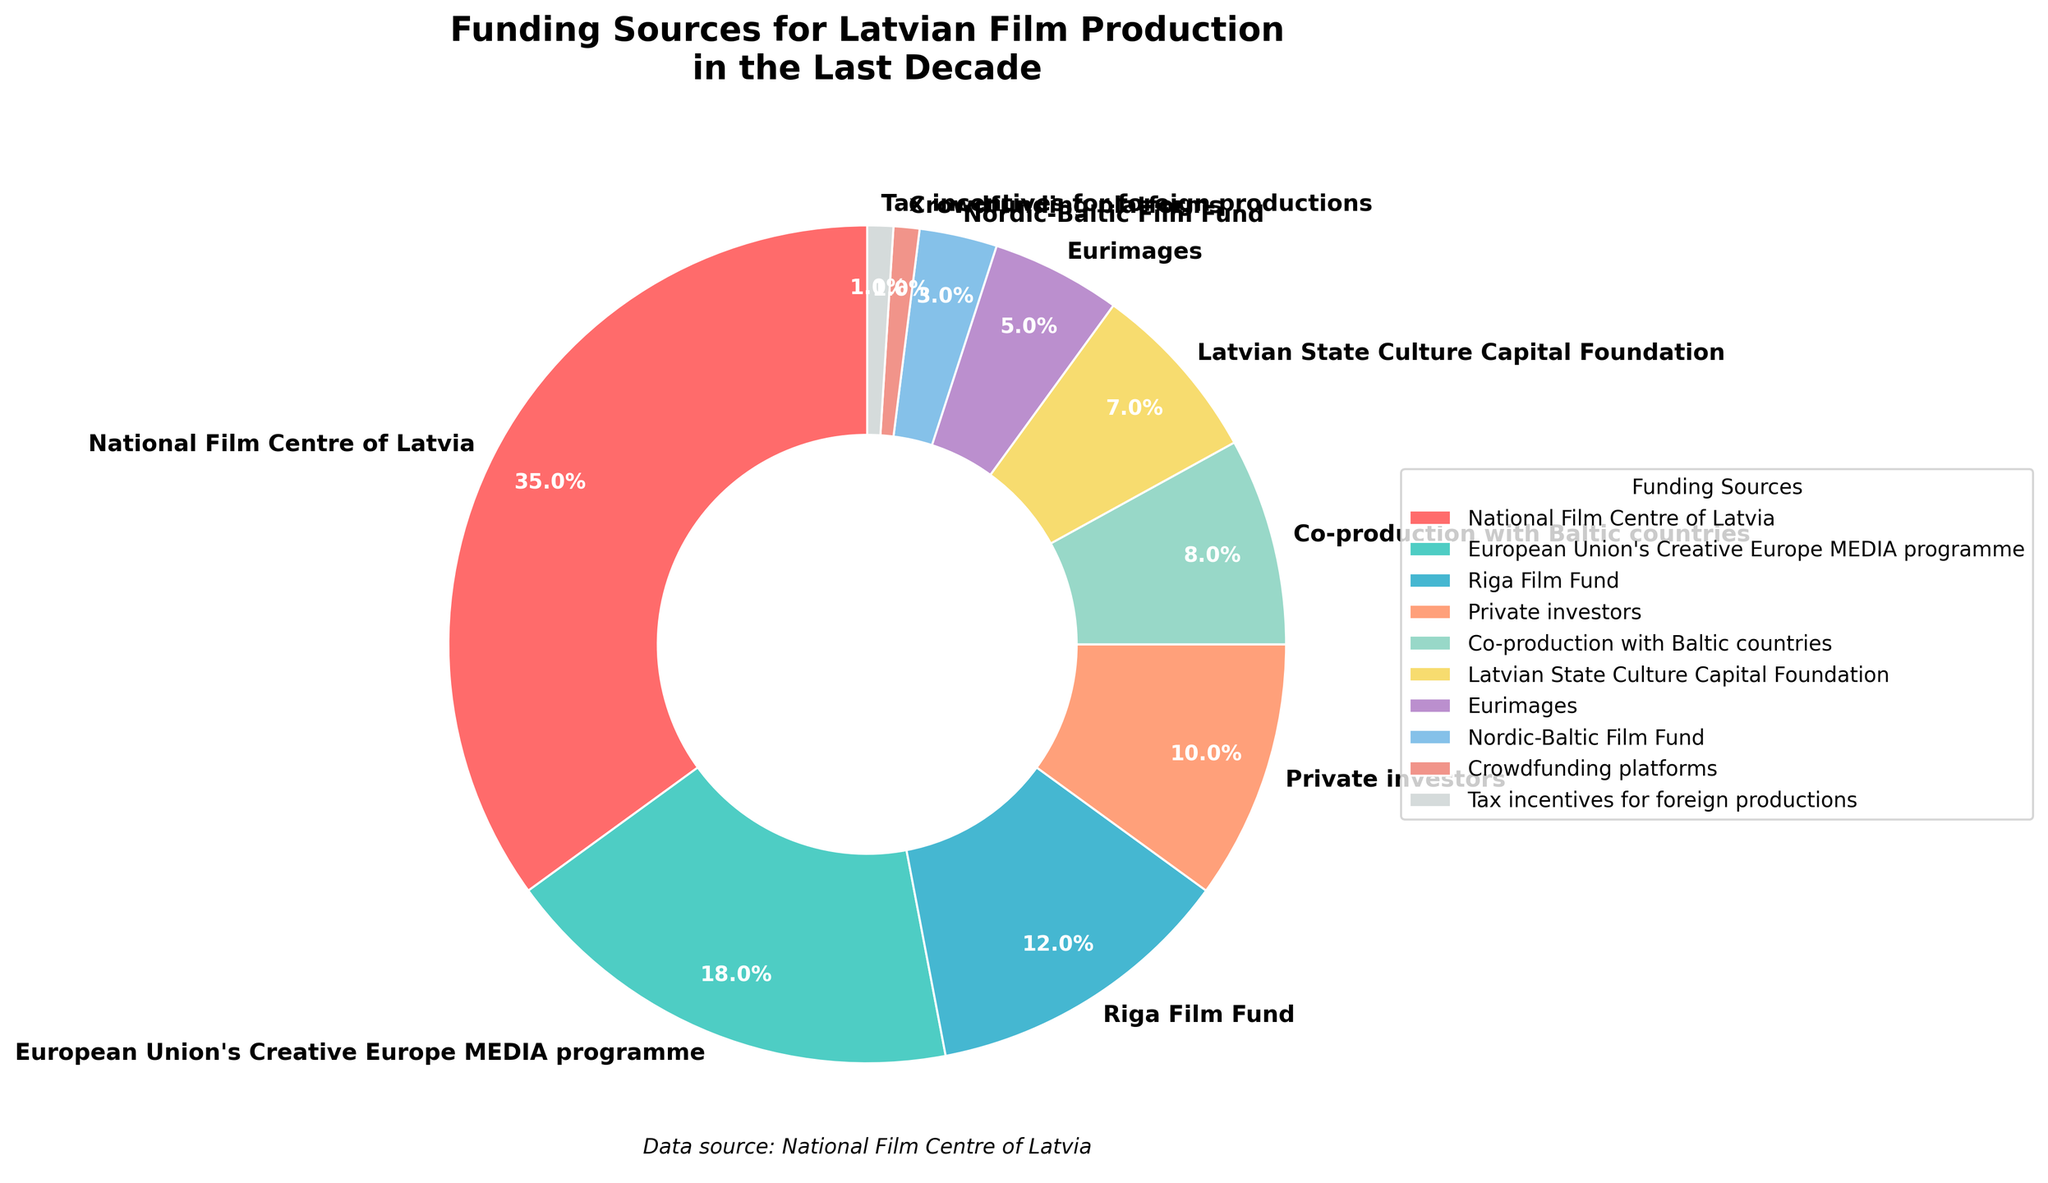Which funding source contributes the most to Latvian film production? The largest segment of the pie chart represents the National Film Centre of Latvia with 35%.
Answer: National Film Centre of Latvia How much more does the National Film Centre of Latvia contribute compared to Private investors? National Film Centre of Latvia contributes 35% and Private investors contribute 10%. The difference is 35% - 10% = 25%.
Answer: 25% Which funding sources contribute exactly 1% to Latvian film production? The smallest segments of the pie chart, each labelled with 1%, correspond to Crowdfunding platforms and Tax incentives for foreign productions.
Answer: Crowdfunding platforms, Tax incentives for foreign productions What is the combined contribution of the European Union's Creative Europe MEDIA programme and the Riga Film Fund? European Union's Creative Europe MEDIA programme contributes 18% and Riga Film Fund contributes 12%. The combined contribution is 18% + 12% = 30%.
Answer: 30% Which funding source has the second highest contribution to Latvian film production? The second largest segment of the pie chart represents the European Union's Creative Europe MEDIA programme with 18%.
Answer: European Union's Creative Europe MEDIA programme What is the combined contribution of all international sources (European Union's Creative Europe MEDIA programme, European co-production funds, and regional funds)? The relevant funding sources are European Union's Creative Europe MEDIA programme (18%), Eurimages (5%), and Nordic-Baltic Film Fund (3%). Their combined contribution is 18% + 5% + 3% = 26%.
Answer: 26% Is the contribution of the Riga Film Fund greater than the combined contribution of Latvian State Culture Capital Foundation and Nordic-Baltic Film Fund? Riga Film Fund contributes 12%. Latvian State Culture Capital Foundation contributes 7% and Nordic-Baltic Film Fund contributes 3%. The combined contribution of the latter two is 7% + 3% = 10%, which is less than 12%.
Answer: Yes What percentage of funding comes from co-production with Baltic countries? The relevant segment of the pie chart shows co-production with Baltic countries contributing 8%.
Answer: 8% What is the combined contribution of Private investors and Crowdfunding platforms? Private investors contribute 10% and Crowdfunding platforms contribute 1%. The combined contribution is 10% + 1% = 11%.
Answer: 11% How much less does Eurimages contribute compared to the National Film Centre of Latvia? Eurimages contributes 5% and National Film Centre of Latvia contributes 35%. The difference is 35% - 5% = 30%.
Answer: 30% 